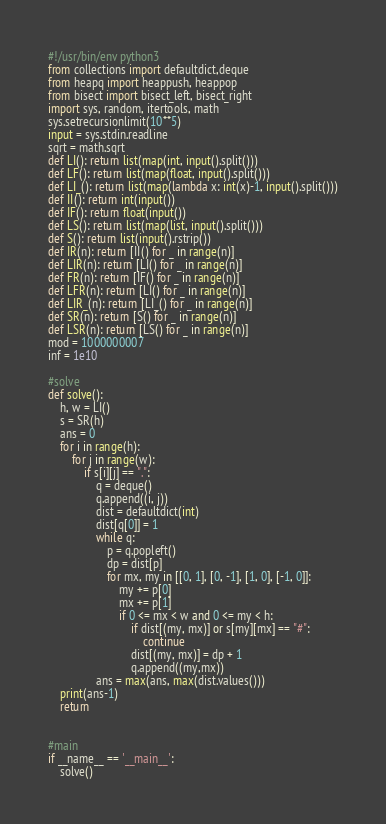<code> <loc_0><loc_0><loc_500><loc_500><_Python_>#!/usr/bin/env python3
from collections import defaultdict,deque
from heapq import heappush, heappop
from bisect import bisect_left, bisect_right
import sys, random, itertools, math
sys.setrecursionlimit(10**5)
input = sys.stdin.readline
sqrt = math.sqrt
def LI(): return list(map(int, input().split()))
def LF(): return list(map(float, input().split()))
def LI_(): return list(map(lambda x: int(x)-1, input().split()))
def II(): return int(input())
def IF(): return float(input())
def LS(): return list(map(list, input().split()))
def S(): return list(input().rstrip())
def IR(n): return [II() for _ in range(n)]
def LIR(n): return [LI() for _ in range(n)]
def FR(n): return [IF() for _ in range(n)]
def LFR(n): return [LI() for _ in range(n)]
def LIR_(n): return [LI_() for _ in range(n)]
def SR(n): return [S() for _ in range(n)]
def LSR(n): return [LS() for _ in range(n)]
mod = 1000000007
inf = 1e10

#solve
def solve():
    h, w = LI()
    s = SR(h)
    ans = 0
    for i in range(h):
        for j in range(w):
            if s[i][j] == ".":
                q = deque()
                q.append((i, j))
                dist = defaultdict(int)
                dist[q[0]] = 1
                while q:
                    p = q.popleft()
                    dp = dist[p]
                    for mx, my in [[0, 1], [0, -1], [1, 0], [-1, 0]]:
                        my += p[0]
                        mx += p[1]
                        if 0 <= mx < w and 0 <= my < h:
                            if dist[(my, mx)] or s[my][mx] == "#":
                                continue
                            dist[(my, mx)] = dp + 1
                            q.append((my,mx))
                ans = max(ans, max(dist.values()))
    print(ans-1)
    return


#main
if __name__ == '__main__':
    solve()
</code> 